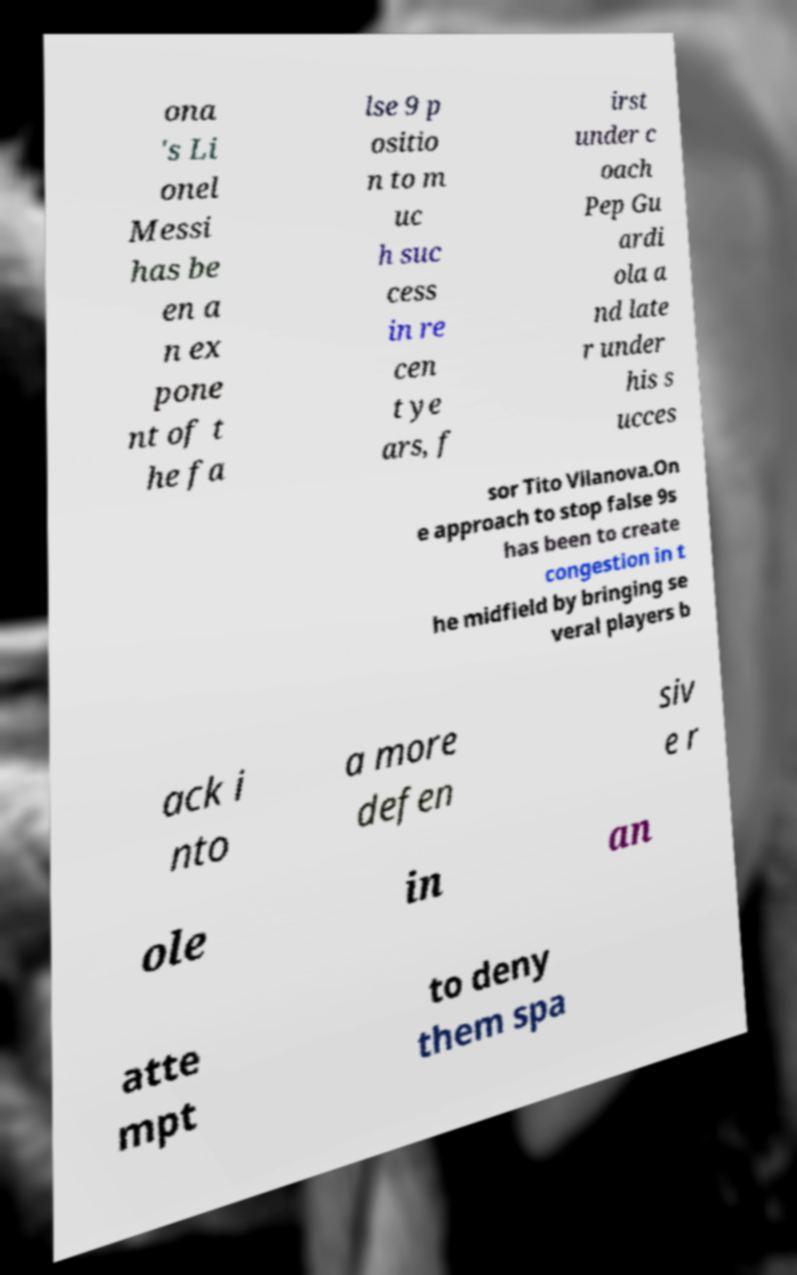Could you assist in decoding the text presented in this image and type it out clearly? ona 's Li onel Messi has be en a n ex pone nt of t he fa lse 9 p ositio n to m uc h suc cess in re cen t ye ars, f irst under c oach Pep Gu ardi ola a nd late r under his s ucces sor Tito Vilanova.On e approach to stop false 9s has been to create congestion in t he midfield by bringing se veral players b ack i nto a more defen siv e r ole in an atte mpt to deny them spa 